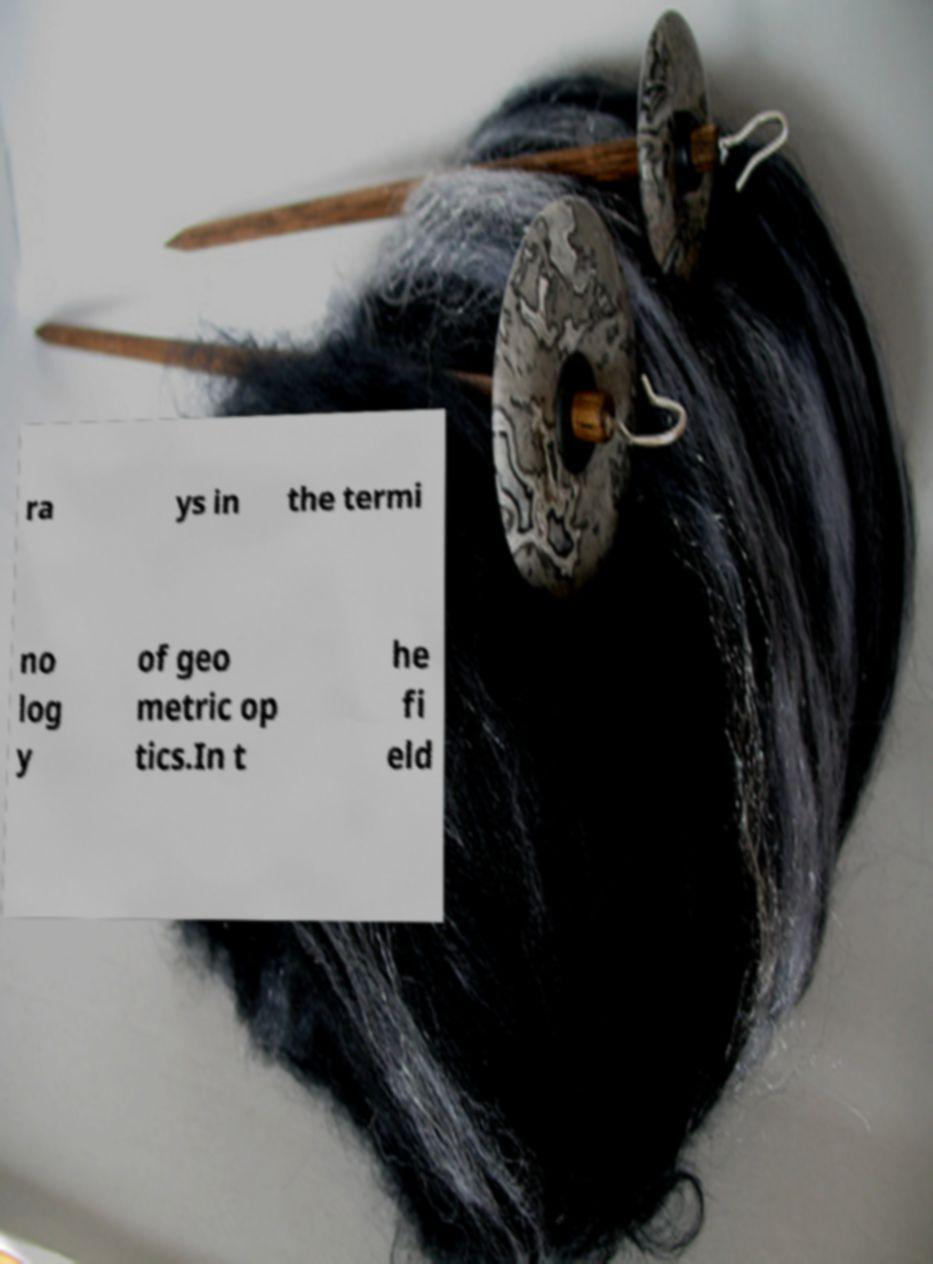Can you accurately transcribe the text from the provided image for me? ra ys in the termi no log y of geo metric op tics.In t he fi eld 